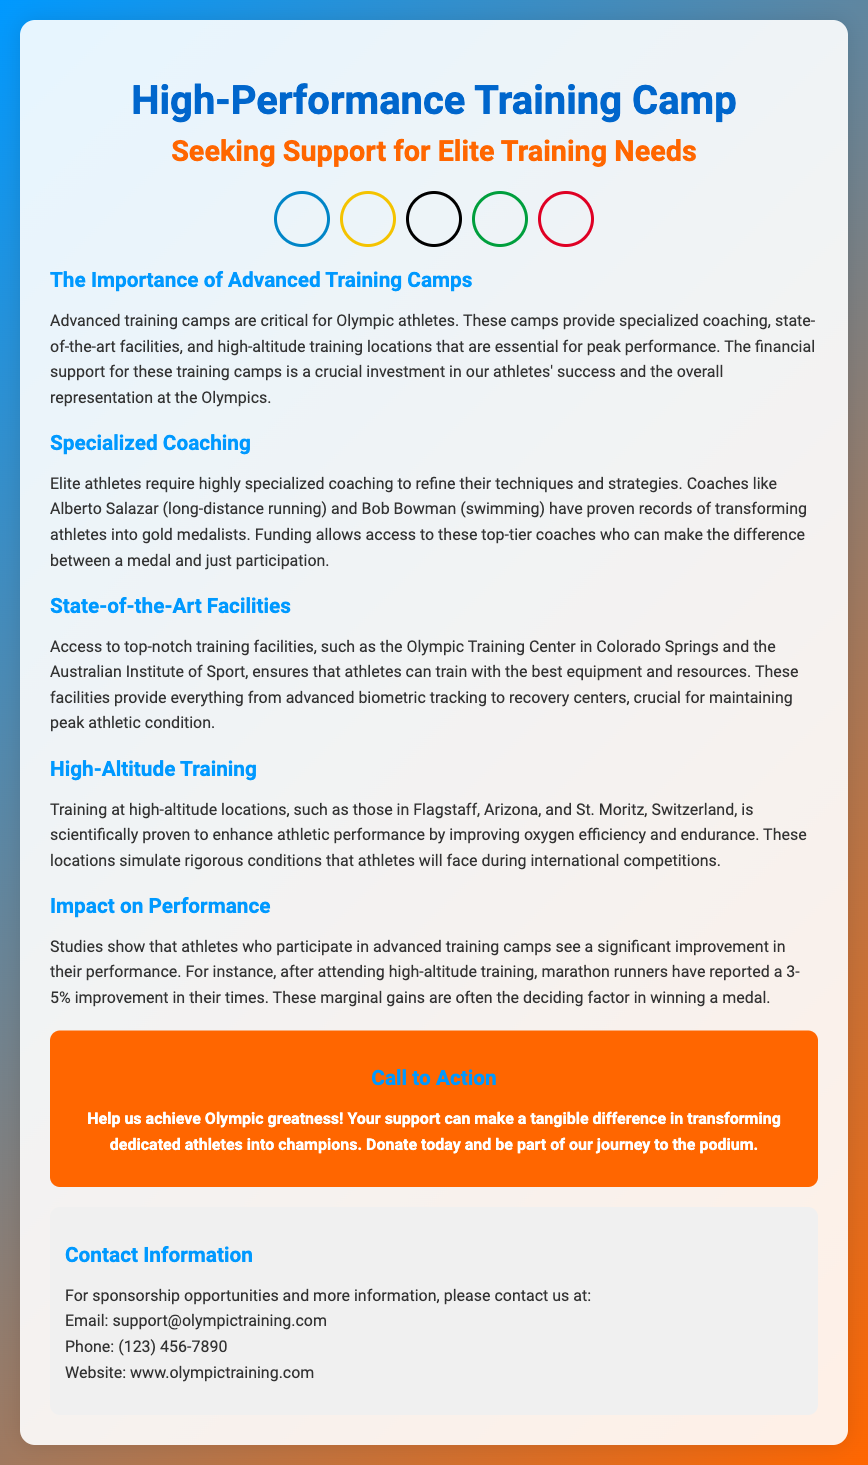What is the title of the flyer? The title of the flyer is stated at the top of the document, referring to the high-performance training camp.
Answer: High-Performance Training Camp: Seeking Support for Elite Training Needs What is the main focus of the training camps? The main focus is highlighted in the introductory paragraph which discusses the need for funding for training.
Answer: Advanced training camps Who are some of the specialized coaches mentioned? The document lists notable coaches as examples of specialized coaching available.
Answer: Alberto Salazar and Bob Bowman Where is one of the elite training facilities located? The document names specific training facilities that are important for athlete preparation.
Answer: Colorado Springs What percentage improvement do marathon runners report after high-altitude training? The document provides specific metrics on performance improvement following training in high altitude.
Answer: 3-5% What is the call to action in the flyer? The flyer encourages readers to contribute and support athletes in their journey.
Answer: Help us achieve Olympic greatness! What type of information is provided in the contact section? The document offers specific details for individuals interested in sponsorship or further information.
Answer: Email, Phone, Website How does high-altitude training benefit athletes? The document explains the advantage of training in oxygen-efficient conditions to enhance performance.
Answer: Improving oxygen efficiency and endurance What is the target audience of the flyer? The document is aimed at potential sponsors and supporters for Olympic training needs.
Answer: Potential sponsors and supporters 